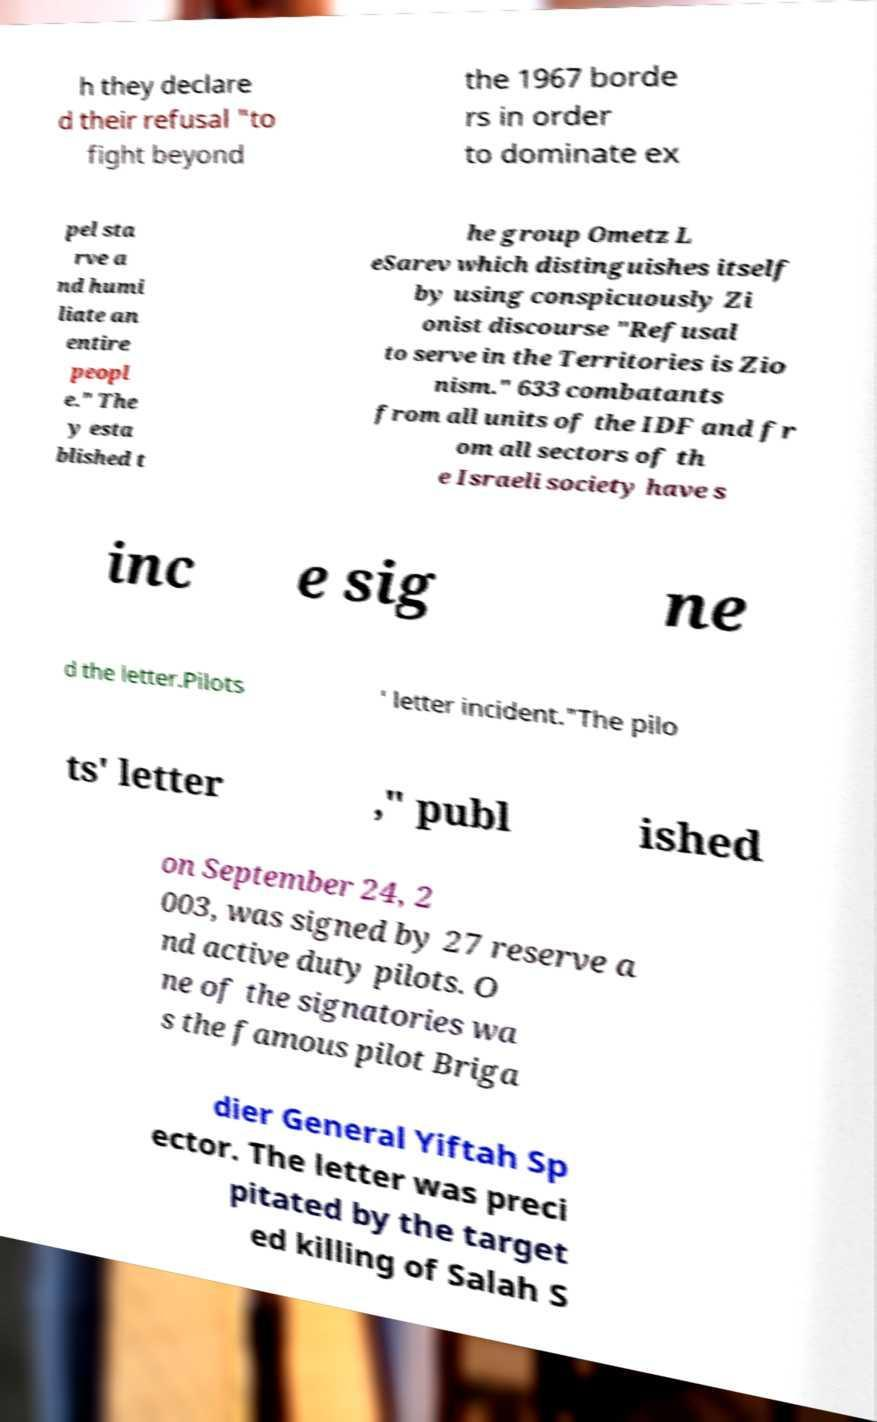Can you accurately transcribe the text from the provided image for me? h they declare d their refusal "to fight beyond the 1967 borde rs in order to dominate ex pel sta rve a nd humi liate an entire peopl e." The y esta blished t he group Ometz L eSarev which distinguishes itself by using conspicuously Zi onist discourse "Refusal to serve in the Territories is Zio nism." 633 combatants from all units of the IDF and fr om all sectors of th e Israeli society have s inc e sig ne d the letter.Pilots ' letter incident."The pilo ts' letter ," publ ished on September 24, 2 003, was signed by 27 reserve a nd active duty pilots. O ne of the signatories wa s the famous pilot Briga dier General Yiftah Sp ector. The letter was preci pitated by the target ed killing of Salah S 